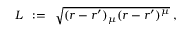Convert formula to latex. <formula><loc_0><loc_0><loc_500><loc_500>L \, \colon = \, \sqrt { ( r - r ^ { \prime } ) _ { \mu } ( r - r ^ { \prime } ) ^ { \mu } } \, ,</formula> 